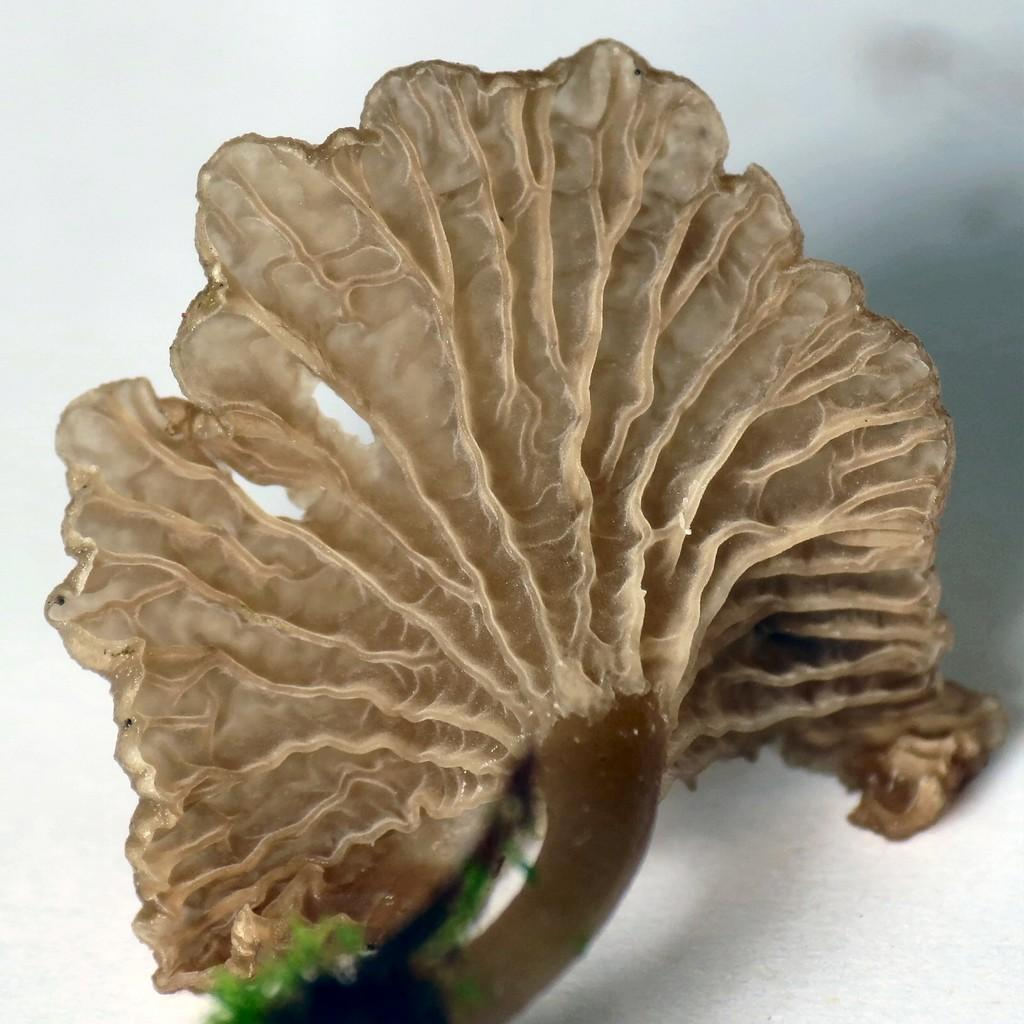What is the main subject of the image? The main subject of the image is coral. Where is the coral located in the image? The coral is placed on a table in the image. What type of wrench is being used to fix the coral in the image? There is no wrench present in the image, and the coral is not being fixed. 